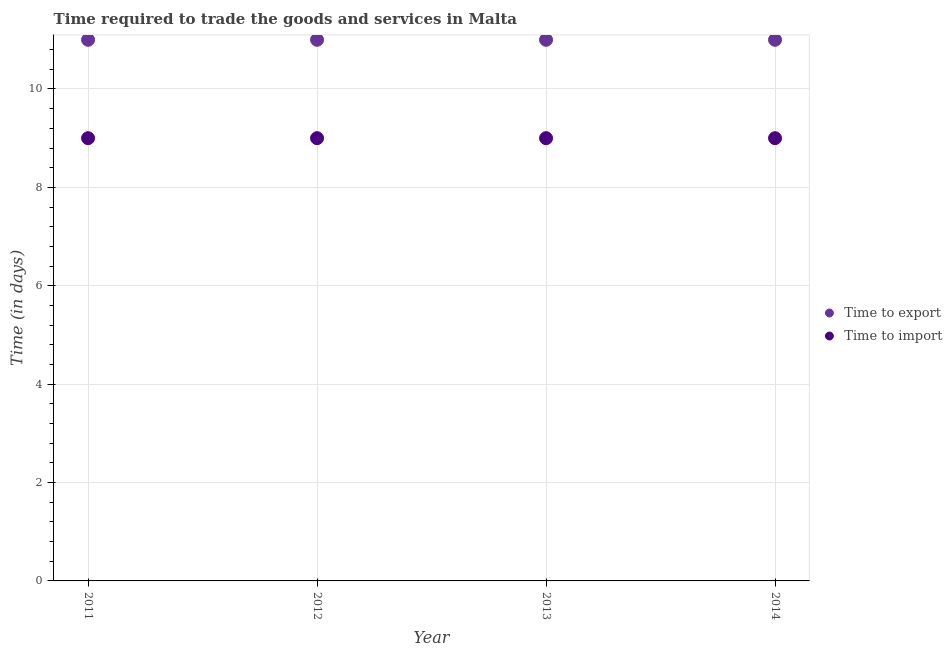Is the number of dotlines equal to the number of legend labels?
Keep it short and to the point. Yes. What is the time to import in 2012?
Make the answer very short. 9. Across all years, what is the maximum time to import?
Offer a terse response. 9. Across all years, what is the minimum time to export?
Your answer should be very brief. 11. In which year was the time to import minimum?
Provide a short and direct response. 2011. What is the total time to export in the graph?
Offer a terse response. 44. What is the difference between the time to export in 2011 and the time to import in 2013?
Make the answer very short. 2. In the year 2013, what is the difference between the time to import and time to export?
Your response must be concise. -2. In how many years, is the time to export greater than 1.2000000000000002 days?
Your answer should be compact. 4. What is the ratio of the time to import in 2012 to that in 2013?
Your response must be concise. 1. Is the time to export in 2011 less than that in 2013?
Make the answer very short. No. Is the difference between the time to import in 2011 and 2013 greater than the difference between the time to export in 2011 and 2013?
Offer a terse response. No. What is the difference between the highest and the second highest time to export?
Give a very brief answer. 0. What is the difference between the highest and the lowest time to import?
Offer a terse response. 0. Is the sum of the time to import in 2012 and 2014 greater than the maximum time to export across all years?
Your answer should be very brief. Yes. How many years are there in the graph?
Your answer should be very brief. 4. Are the values on the major ticks of Y-axis written in scientific E-notation?
Your response must be concise. No. Where does the legend appear in the graph?
Offer a very short reply. Center right. What is the title of the graph?
Give a very brief answer. Time required to trade the goods and services in Malta. What is the label or title of the Y-axis?
Your response must be concise. Time (in days). What is the Time (in days) of Time to export in 2011?
Make the answer very short. 11. What is the Time (in days) of Time to import in 2011?
Keep it short and to the point. 9. What is the Time (in days) in Time to export in 2012?
Offer a terse response. 11. What is the Time (in days) of Time to import in 2012?
Your answer should be compact. 9. What is the Time (in days) in Time to export in 2014?
Offer a terse response. 11. What is the Time (in days) in Time to import in 2014?
Provide a succinct answer. 9. Across all years, what is the maximum Time (in days) of Time to export?
Offer a very short reply. 11. What is the total Time (in days) of Time to export in the graph?
Ensure brevity in your answer.  44. What is the difference between the Time (in days) in Time to import in 2011 and that in 2012?
Keep it short and to the point. 0. What is the difference between the Time (in days) in Time to export in 2011 and that in 2013?
Offer a very short reply. 0. What is the difference between the Time (in days) of Time to export in 2011 and that in 2014?
Your answer should be very brief. 0. What is the difference between the Time (in days) of Time to export in 2012 and that in 2013?
Your response must be concise. 0. What is the difference between the Time (in days) in Time to export in 2012 and that in 2014?
Ensure brevity in your answer.  0. What is the difference between the Time (in days) in Time to export in 2013 and that in 2014?
Keep it short and to the point. 0. What is the difference between the Time (in days) of Time to export in 2011 and the Time (in days) of Time to import in 2013?
Give a very brief answer. 2. What is the difference between the Time (in days) in Time to export in 2011 and the Time (in days) in Time to import in 2014?
Your answer should be compact. 2. What is the difference between the Time (in days) in Time to export in 2012 and the Time (in days) in Time to import in 2013?
Your answer should be compact. 2. What is the difference between the Time (in days) of Time to export in 2013 and the Time (in days) of Time to import in 2014?
Ensure brevity in your answer.  2. What is the average Time (in days) of Time to export per year?
Your response must be concise. 11. What is the average Time (in days) of Time to import per year?
Provide a short and direct response. 9. What is the ratio of the Time (in days) of Time to export in 2011 to that in 2012?
Provide a succinct answer. 1. What is the ratio of the Time (in days) of Time to export in 2011 to that in 2013?
Your answer should be compact. 1. What is the ratio of the Time (in days) of Time to import in 2011 to that in 2013?
Ensure brevity in your answer.  1. What is the ratio of the Time (in days) in Time to export in 2011 to that in 2014?
Give a very brief answer. 1. What is the ratio of the Time (in days) of Time to import in 2011 to that in 2014?
Your answer should be compact. 1. What is the ratio of the Time (in days) of Time to export in 2013 to that in 2014?
Ensure brevity in your answer.  1. What is the difference between the highest and the second highest Time (in days) of Time to export?
Keep it short and to the point. 0. What is the difference between the highest and the second highest Time (in days) in Time to import?
Make the answer very short. 0. 